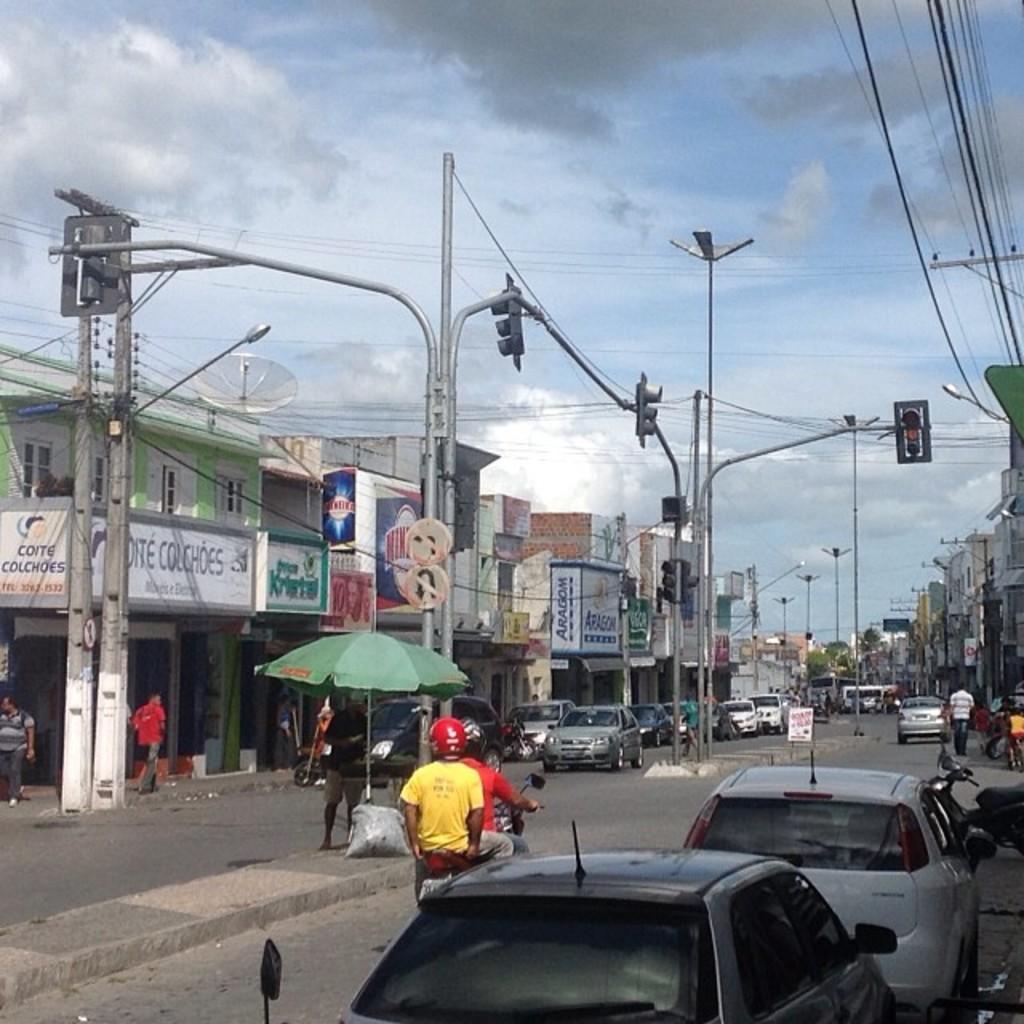Please provide a concise description of this image. There are two people sitting on bike and wore helmets and we can see cars and umbrella. We can see traffic signals,lights and boards on poles and we can see wires. In the background we can see buildings,vehicles on the road,people and sky. 